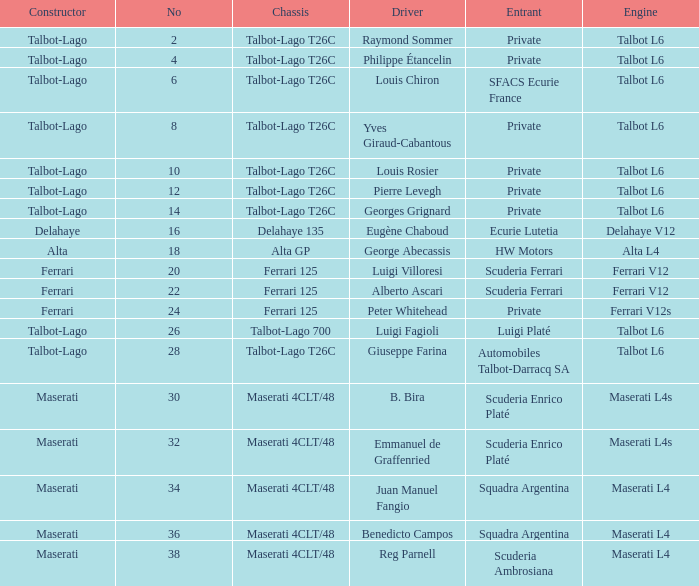Write the full table. {'header': ['Constructor', 'No', 'Chassis', 'Driver', 'Entrant', 'Engine'], 'rows': [['Talbot-Lago', '2', 'Talbot-Lago T26C', 'Raymond Sommer', 'Private', 'Talbot L6'], ['Talbot-Lago', '4', 'Talbot-Lago T26C', 'Philippe Étancelin', 'Private', 'Talbot L6'], ['Talbot-Lago', '6', 'Talbot-Lago T26C', 'Louis Chiron', 'SFACS Ecurie France', 'Talbot L6'], ['Talbot-Lago', '8', 'Talbot-Lago T26C', 'Yves Giraud-Cabantous', 'Private', 'Talbot L6'], ['Talbot-Lago', '10', 'Talbot-Lago T26C', 'Louis Rosier', 'Private', 'Talbot L6'], ['Talbot-Lago', '12', 'Talbot-Lago T26C', 'Pierre Levegh', 'Private', 'Talbot L6'], ['Talbot-Lago', '14', 'Talbot-Lago T26C', 'Georges Grignard', 'Private', 'Talbot L6'], ['Delahaye', '16', 'Delahaye 135', 'Eugène Chaboud', 'Ecurie Lutetia', 'Delahaye V12'], ['Alta', '18', 'Alta GP', 'George Abecassis', 'HW Motors', 'Alta L4'], ['Ferrari', '20', 'Ferrari 125', 'Luigi Villoresi', 'Scuderia Ferrari', 'Ferrari V12'], ['Ferrari', '22', 'Ferrari 125', 'Alberto Ascari', 'Scuderia Ferrari', 'Ferrari V12'], ['Ferrari', '24', 'Ferrari 125', 'Peter Whitehead', 'Private', 'Ferrari V12s'], ['Talbot-Lago', '26', 'Talbot-Lago 700', 'Luigi Fagioli', 'Luigi Platé', 'Talbot L6'], ['Talbot-Lago', '28', 'Talbot-Lago T26C', 'Giuseppe Farina', 'Automobiles Talbot-Darracq SA', 'Talbot L6'], ['Maserati', '30', 'Maserati 4CLT/48', 'B. Bira', 'Scuderia Enrico Platé', 'Maserati L4s'], ['Maserati', '32', 'Maserati 4CLT/48', 'Emmanuel de Graffenried', 'Scuderia Enrico Platé', 'Maserati L4s'], ['Maserati', '34', 'Maserati 4CLT/48', 'Juan Manuel Fangio', 'Squadra Argentina', 'Maserati L4'], ['Maserati', '36', 'Maserati 4CLT/48', 'Benedicto Campos', 'Squadra Argentina', 'Maserati L4'], ['Maserati', '38', 'Maserati 4CLT/48', 'Reg Parnell', 'Scuderia Ambrosiana', 'Maserati L4']]} Name the engine for ecurie lutetia Delahaye V12. 